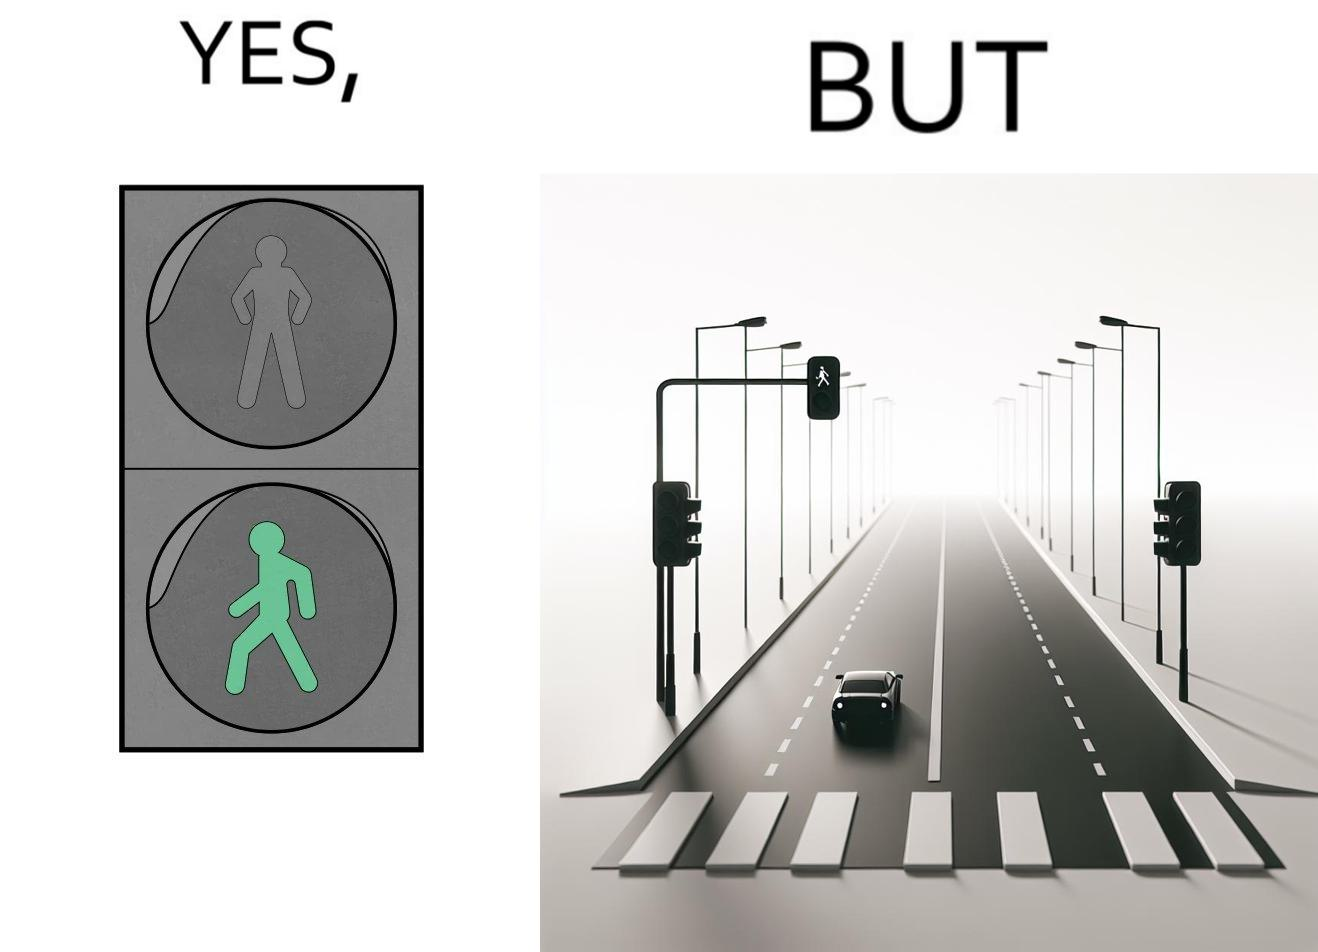What does this image depict? The image is funny because while walk signs are very useful for pedestrians to be able to cross roads safely, the become unnecessary and annoying for car drivers when these signals turn green even when there is no pedestrian tring to cross the road. 